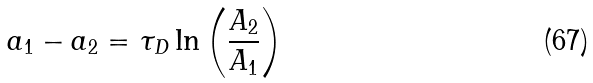<formula> <loc_0><loc_0><loc_500><loc_500>a _ { 1 } - a _ { 2 } = \tau _ { D } \ln \left ( \frac { A _ { 2 } } { A _ { 1 } } \right )</formula> 